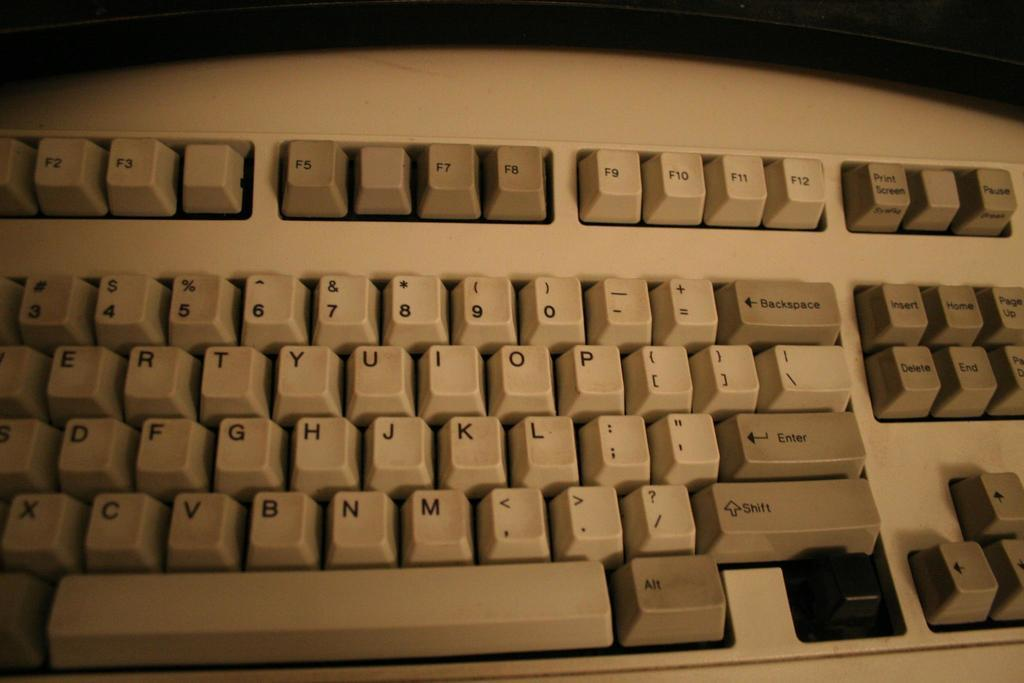<image>
Share a concise interpretation of the image provided. A keyboard has all of its keys including the shift and enter keys. 